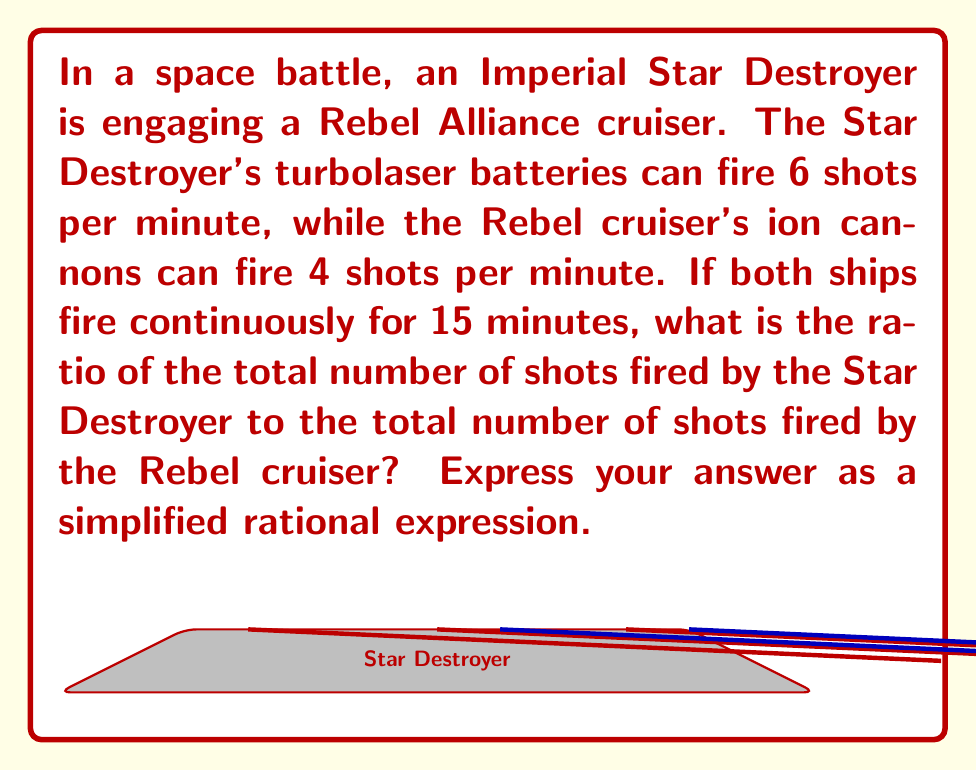Show me your answer to this math problem. Let's approach this step-by-step:

1) First, let's calculate the total number of shots fired by each ship in 15 minutes.

   For the Star Destroyer:
   $$ \text{Shots per minute} \times \text{Number of minutes} = 6 \times 15 = 90 \text{ shots} $$

   For the Rebel cruiser:
   $$ \text{Shots per minute} \times \text{Number of minutes} = 4 \times 15 = 60 \text{ shots} $$

2) Now, we need to find the ratio of these two numbers:

   $$ \text{Ratio} = \frac{\text{Star Destroyer shots}}{\text{Rebel cruiser shots}} = \frac{90}{60} $$

3) This fraction can be simplified by dividing both the numerator and denominator by their greatest common divisor (GCD). The GCD of 90 and 60 is 30.

   $$ \frac{90}{60} = \frac{90 \div 30}{60 \div 30} = \frac{3}{2} $$

Therefore, the simplified ratio of shots fired by the Star Destroyer to shots fired by the Rebel cruiser is 3:2.
Answer: $\frac{3}{2}$ 